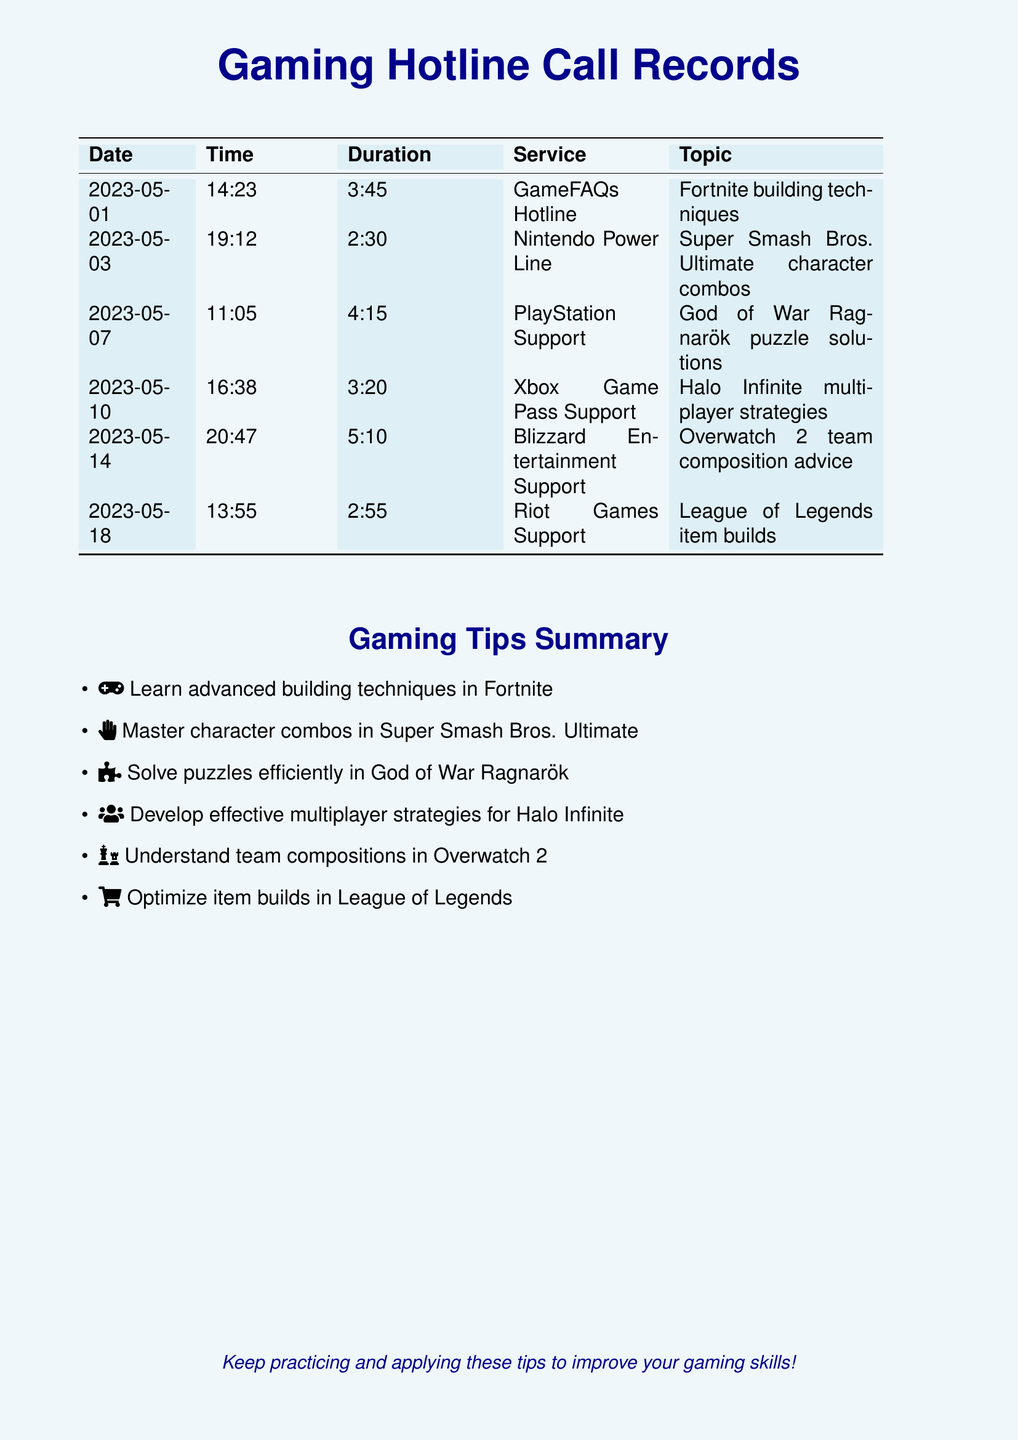What is the first call date? The document lists the first call date at the top of the call records section.
Answer: 2023-05-01 What service was called on May 10? The document specifies the service associated with the call made on this date.
Answer: Xbox Game Pass Support Which game was discussed in the call on May 14? The topic of the call made on this date is mentioned under the service section of the records.
Answer: Overwatch 2 How long was the call about League of Legends? The duration of the specific call is provided in the telephone records table.
Answer: 2:55 What is one tip mentioned for Fortnite? The summary section provides a specific gameplay advice for this game.
Answer: Learn advanced building techniques Which support line provides tips for God of War Ragnarök? The corresponding service for this game is noted in the call records.
Answer: PlayStation Support What is the topic of the call on May 18? The document indicates the specific item built discussed during this call.
Answer: League of Legends item builds How many calls were made to the Nintendo Power Line? The document lists each call, and the count for this specific service is determined by reviewing the calls.
Answer: 1 